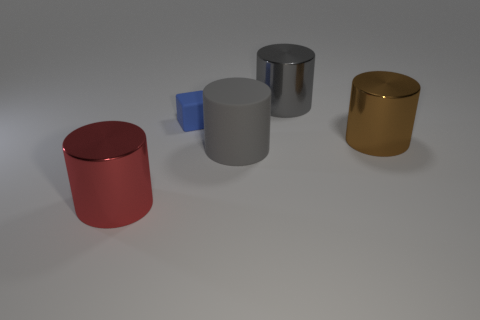Add 3 small brown metal cylinders. How many objects exist? 8 Subtract all cubes. How many objects are left? 4 Add 1 big red cubes. How many big red cubes exist? 1 Subtract 1 blue cubes. How many objects are left? 4 Subtract all shiny cylinders. Subtract all large gray shiny cylinders. How many objects are left? 1 Add 1 small cubes. How many small cubes are left? 2 